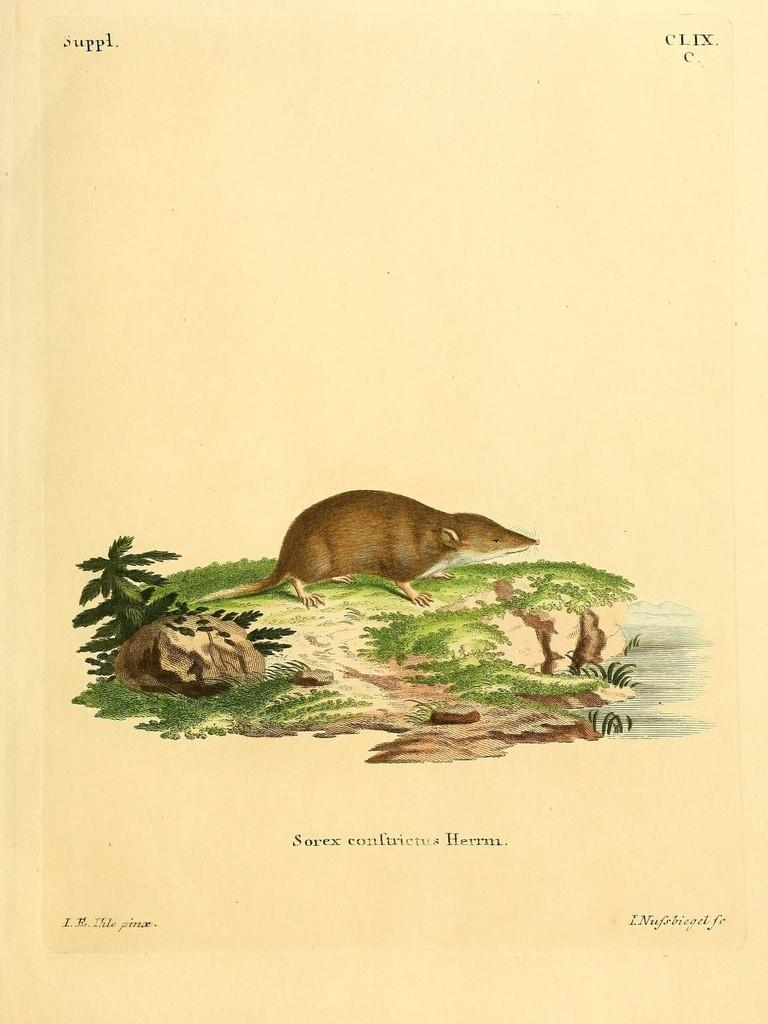What is present in the image that contains both images and text? There is a poster in the image that contains images and text. What type of insect can be seen crawling on the poster in the image? There are no insects present on the poster in the image. 